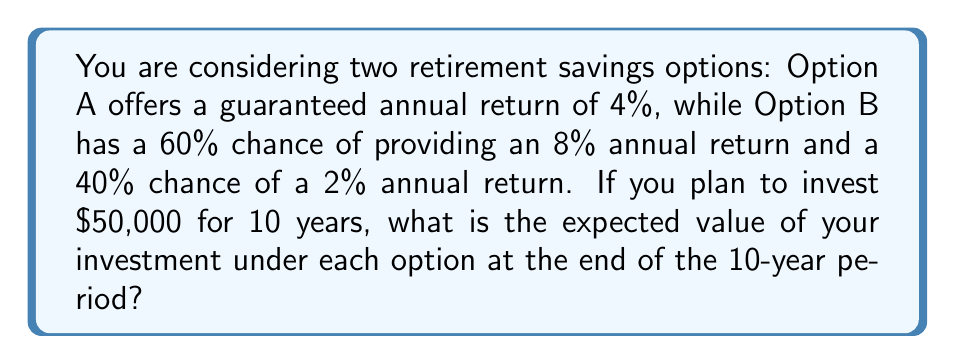Help me with this question. Let's calculate the expected value for each option:

Option A:
This is a straightforward compound interest calculation. The formula for compound interest is:

$$A = P(1 + r)^n$$

Where:
$A$ = final amount
$P$ = principal (initial investment)
$r$ = annual interest rate
$n$ = number of years

For Option A:
$P = \$50,000$
$r = 0.04$ (4%)
$n = 10$ years

$$A = 50,000(1 + 0.04)^{10} = 50,000(1.4802) = \$74,012.07$$

Option B:
For this option, we need to calculate the expected value using probability-weighted outcomes.

Expected annual return = (0.60 × 8%) + (0.40 × 2%) = 4.8% + 0.8% = 5.6%

Now we can use the compound interest formula with the expected annual return:

$$A = 50,000(1 + 0.056)^{10} = 50,000(1.7246) = \$86,231.91$$

To verify this result, we can also calculate the two possible outcomes separately and then take their weighted average:

8% return: $50,000(1 + 0.08)^{10} = \$107,945.64$
2% return: $50,000(1 + 0.02)^{10} = \$60,949.54$

Expected Value = (0.60 × $107,945.64) + (0.40 × $60,949.54) = $86,231.91

This confirms our earlier calculation.
Answer: The expected value after 10 years is $74,012.07 for Option A and $86,231.91 for Option B. 